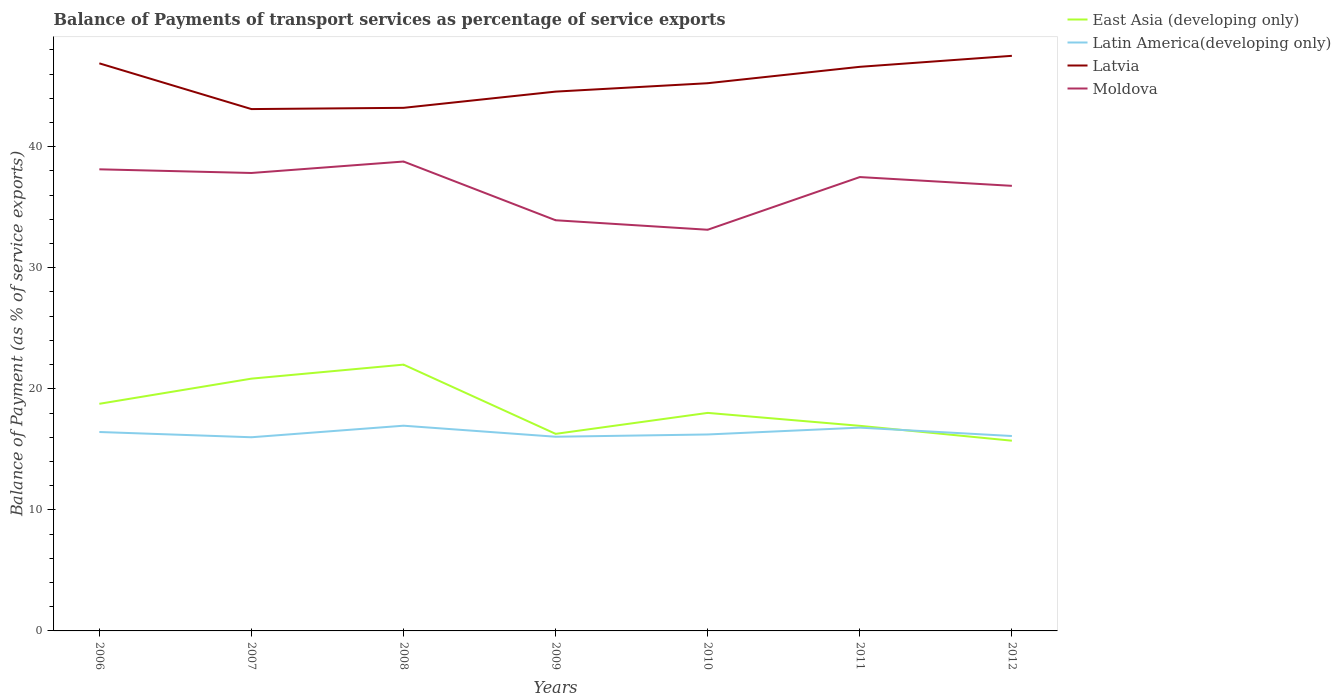How many different coloured lines are there?
Provide a succinct answer. 4. Across all years, what is the maximum balance of payments of transport services in Moldova?
Offer a terse response. 33.14. What is the total balance of payments of transport services in Latin America(developing only) in the graph?
Provide a short and direct response. 0.91. What is the difference between the highest and the second highest balance of payments of transport services in Moldova?
Your answer should be very brief. 5.64. What is the difference between the highest and the lowest balance of payments of transport services in East Asia (developing only)?
Offer a terse response. 3. Is the balance of payments of transport services in Latvia strictly greater than the balance of payments of transport services in Moldova over the years?
Make the answer very short. No. How many lines are there?
Make the answer very short. 4. How many years are there in the graph?
Ensure brevity in your answer.  7. Does the graph contain any zero values?
Offer a terse response. No. Does the graph contain grids?
Provide a short and direct response. No. How many legend labels are there?
Offer a very short reply. 4. What is the title of the graph?
Keep it short and to the point. Balance of Payments of transport services as percentage of service exports. What is the label or title of the X-axis?
Provide a short and direct response. Years. What is the label or title of the Y-axis?
Your response must be concise. Balance of Payment (as % of service exports). What is the Balance of Payment (as % of service exports) of East Asia (developing only) in 2006?
Ensure brevity in your answer.  18.76. What is the Balance of Payment (as % of service exports) of Latin America(developing only) in 2006?
Make the answer very short. 16.43. What is the Balance of Payment (as % of service exports) in Latvia in 2006?
Offer a terse response. 46.89. What is the Balance of Payment (as % of service exports) in Moldova in 2006?
Make the answer very short. 38.13. What is the Balance of Payment (as % of service exports) in East Asia (developing only) in 2007?
Your answer should be compact. 20.84. What is the Balance of Payment (as % of service exports) in Latin America(developing only) in 2007?
Your answer should be compact. 16. What is the Balance of Payment (as % of service exports) in Latvia in 2007?
Ensure brevity in your answer.  43.11. What is the Balance of Payment (as % of service exports) of Moldova in 2007?
Keep it short and to the point. 37.83. What is the Balance of Payment (as % of service exports) of East Asia (developing only) in 2008?
Offer a terse response. 22. What is the Balance of Payment (as % of service exports) in Latin America(developing only) in 2008?
Provide a succinct answer. 16.95. What is the Balance of Payment (as % of service exports) of Latvia in 2008?
Offer a very short reply. 43.21. What is the Balance of Payment (as % of service exports) in Moldova in 2008?
Make the answer very short. 38.78. What is the Balance of Payment (as % of service exports) of East Asia (developing only) in 2009?
Make the answer very short. 16.28. What is the Balance of Payment (as % of service exports) of Latin America(developing only) in 2009?
Your answer should be very brief. 16.04. What is the Balance of Payment (as % of service exports) in Latvia in 2009?
Make the answer very short. 44.55. What is the Balance of Payment (as % of service exports) in Moldova in 2009?
Your answer should be very brief. 33.93. What is the Balance of Payment (as % of service exports) of East Asia (developing only) in 2010?
Your response must be concise. 18.01. What is the Balance of Payment (as % of service exports) of Latin America(developing only) in 2010?
Provide a short and direct response. 16.23. What is the Balance of Payment (as % of service exports) in Latvia in 2010?
Offer a very short reply. 45.25. What is the Balance of Payment (as % of service exports) in Moldova in 2010?
Offer a very short reply. 33.14. What is the Balance of Payment (as % of service exports) in East Asia (developing only) in 2011?
Provide a short and direct response. 16.94. What is the Balance of Payment (as % of service exports) of Latin America(developing only) in 2011?
Give a very brief answer. 16.79. What is the Balance of Payment (as % of service exports) of Latvia in 2011?
Give a very brief answer. 46.6. What is the Balance of Payment (as % of service exports) in Moldova in 2011?
Make the answer very short. 37.49. What is the Balance of Payment (as % of service exports) of East Asia (developing only) in 2012?
Your answer should be very brief. 15.71. What is the Balance of Payment (as % of service exports) in Latin America(developing only) in 2012?
Provide a short and direct response. 16.1. What is the Balance of Payment (as % of service exports) of Latvia in 2012?
Your answer should be compact. 47.51. What is the Balance of Payment (as % of service exports) of Moldova in 2012?
Your answer should be compact. 36.77. Across all years, what is the maximum Balance of Payment (as % of service exports) in East Asia (developing only)?
Make the answer very short. 22. Across all years, what is the maximum Balance of Payment (as % of service exports) of Latin America(developing only)?
Your response must be concise. 16.95. Across all years, what is the maximum Balance of Payment (as % of service exports) of Latvia?
Keep it short and to the point. 47.51. Across all years, what is the maximum Balance of Payment (as % of service exports) in Moldova?
Make the answer very short. 38.78. Across all years, what is the minimum Balance of Payment (as % of service exports) of East Asia (developing only)?
Keep it short and to the point. 15.71. Across all years, what is the minimum Balance of Payment (as % of service exports) in Latin America(developing only)?
Your answer should be compact. 16. Across all years, what is the minimum Balance of Payment (as % of service exports) in Latvia?
Keep it short and to the point. 43.11. Across all years, what is the minimum Balance of Payment (as % of service exports) in Moldova?
Make the answer very short. 33.14. What is the total Balance of Payment (as % of service exports) in East Asia (developing only) in the graph?
Your response must be concise. 128.55. What is the total Balance of Payment (as % of service exports) of Latin America(developing only) in the graph?
Give a very brief answer. 114.55. What is the total Balance of Payment (as % of service exports) of Latvia in the graph?
Offer a very short reply. 317.11. What is the total Balance of Payment (as % of service exports) of Moldova in the graph?
Make the answer very short. 256.07. What is the difference between the Balance of Payment (as % of service exports) in East Asia (developing only) in 2006 and that in 2007?
Offer a terse response. -2.08. What is the difference between the Balance of Payment (as % of service exports) of Latin America(developing only) in 2006 and that in 2007?
Ensure brevity in your answer.  0.43. What is the difference between the Balance of Payment (as % of service exports) in Latvia in 2006 and that in 2007?
Your response must be concise. 3.78. What is the difference between the Balance of Payment (as % of service exports) in Moldova in 2006 and that in 2007?
Your response must be concise. 0.3. What is the difference between the Balance of Payment (as % of service exports) in East Asia (developing only) in 2006 and that in 2008?
Offer a terse response. -3.24. What is the difference between the Balance of Payment (as % of service exports) in Latin America(developing only) in 2006 and that in 2008?
Your answer should be very brief. -0.52. What is the difference between the Balance of Payment (as % of service exports) of Latvia in 2006 and that in 2008?
Provide a succinct answer. 3.67. What is the difference between the Balance of Payment (as % of service exports) of Moldova in 2006 and that in 2008?
Ensure brevity in your answer.  -0.64. What is the difference between the Balance of Payment (as % of service exports) of East Asia (developing only) in 2006 and that in 2009?
Provide a succinct answer. 2.48. What is the difference between the Balance of Payment (as % of service exports) in Latin America(developing only) in 2006 and that in 2009?
Provide a short and direct response. 0.39. What is the difference between the Balance of Payment (as % of service exports) of Latvia in 2006 and that in 2009?
Make the answer very short. 2.33. What is the difference between the Balance of Payment (as % of service exports) of Moldova in 2006 and that in 2009?
Give a very brief answer. 4.21. What is the difference between the Balance of Payment (as % of service exports) of East Asia (developing only) in 2006 and that in 2010?
Make the answer very short. 0.75. What is the difference between the Balance of Payment (as % of service exports) of Latin America(developing only) in 2006 and that in 2010?
Give a very brief answer. 0.2. What is the difference between the Balance of Payment (as % of service exports) in Latvia in 2006 and that in 2010?
Your response must be concise. 1.64. What is the difference between the Balance of Payment (as % of service exports) of Moldova in 2006 and that in 2010?
Provide a succinct answer. 4.99. What is the difference between the Balance of Payment (as % of service exports) in East Asia (developing only) in 2006 and that in 2011?
Provide a short and direct response. 1.82. What is the difference between the Balance of Payment (as % of service exports) of Latin America(developing only) in 2006 and that in 2011?
Your response must be concise. -0.36. What is the difference between the Balance of Payment (as % of service exports) in Latvia in 2006 and that in 2011?
Give a very brief answer. 0.29. What is the difference between the Balance of Payment (as % of service exports) in Moldova in 2006 and that in 2011?
Your answer should be very brief. 0.64. What is the difference between the Balance of Payment (as % of service exports) of East Asia (developing only) in 2006 and that in 2012?
Offer a very short reply. 3.05. What is the difference between the Balance of Payment (as % of service exports) of Latin America(developing only) in 2006 and that in 2012?
Provide a short and direct response. 0.33. What is the difference between the Balance of Payment (as % of service exports) of Latvia in 2006 and that in 2012?
Keep it short and to the point. -0.62. What is the difference between the Balance of Payment (as % of service exports) in Moldova in 2006 and that in 2012?
Provide a short and direct response. 1.36. What is the difference between the Balance of Payment (as % of service exports) in East Asia (developing only) in 2007 and that in 2008?
Your answer should be very brief. -1.16. What is the difference between the Balance of Payment (as % of service exports) in Latin America(developing only) in 2007 and that in 2008?
Your response must be concise. -0.95. What is the difference between the Balance of Payment (as % of service exports) of Latvia in 2007 and that in 2008?
Make the answer very short. -0.1. What is the difference between the Balance of Payment (as % of service exports) in Moldova in 2007 and that in 2008?
Make the answer very short. -0.95. What is the difference between the Balance of Payment (as % of service exports) in East Asia (developing only) in 2007 and that in 2009?
Keep it short and to the point. 4.56. What is the difference between the Balance of Payment (as % of service exports) in Latin America(developing only) in 2007 and that in 2009?
Provide a succinct answer. -0.04. What is the difference between the Balance of Payment (as % of service exports) of Latvia in 2007 and that in 2009?
Offer a terse response. -1.44. What is the difference between the Balance of Payment (as % of service exports) in Moldova in 2007 and that in 2009?
Your answer should be very brief. 3.91. What is the difference between the Balance of Payment (as % of service exports) of East Asia (developing only) in 2007 and that in 2010?
Keep it short and to the point. 2.83. What is the difference between the Balance of Payment (as % of service exports) of Latin America(developing only) in 2007 and that in 2010?
Your answer should be compact. -0.23. What is the difference between the Balance of Payment (as % of service exports) in Latvia in 2007 and that in 2010?
Ensure brevity in your answer.  -2.14. What is the difference between the Balance of Payment (as % of service exports) of Moldova in 2007 and that in 2010?
Give a very brief answer. 4.69. What is the difference between the Balance of Payment (as % of service exports) of East Asia (developing only) in 2007 and that in 2011?
Your answer should be very brief. 3.9. What is the difference between the Balance of Payment (as % of service exports) of Latin America(developing only) in 2007 and that in 2011?
Your response must be concise. -0.79. What is the difference between the Balance of Payment (as % of service exports) of Latvia in 2007 and that in 2011?
Your response must be concise. -3.49. What is the difference between the Balance of Payment (as % of service exports) of Moldova in 2007 and that in 2011?
Your response must be concise. 0.34. What is the difference between the Balance of Payment (as % of service exports) of East Asia (developing only) in 2007 and that in 2012?
Offer a very short reply. 5.13. What is the difference between the Balance of Payment (as % of service exports) in Latin America(developing only) in 2007 and that in 2012?
Your answer should be very brief. -0.1. What is the difference between the Balance of Payment (as % of service exports) in Latvia in 2007 and that in 2012?
Offer a very short reply. -4.4. What is the difference between the Balance of Payment (as % of service exports) of Moldova in 2007 and that in 2012?
Ensure brevity in your answer.  1.06. What is the difference between the Balance of Payment (as % of service exports) of East Asia (developing only) in 2008 and that in 2009?
Keep it short and to the point. 5.72. What is the difference between the Balance of Payment (as % of service exports) in Latin America(developing only) in 2008 and that in 2009?
Offer a terse response. 0.91. What is the difference between the Balance of Payment (as % of service exports) in Latvia in 2008 and that in 2009?
Keep it short and to the point. -1.34. What is the difference between the Balance of Payment (as % of service exports) of Moldova in 2008 and that in 2009?
Offer a very short reply. 4.85. What is the difference between the Balance of Payment (as % of service exports) in East Asia (developing only) in 2008 and that in 2010?
Make the answer very short. 3.99. What is the difference between the Balance of Payment (as % of service exports) of Latin America(developing only) in 2008 and that in 2010?
Provide a short and direct response. 0.72. What is the difference between the Balance of Payment (as % of service exports) in Latvia in 2008 and that in 2010?
Give a very brief answer. -2.03. What is the difference between the Balance of Payment (as % of service exports) of Moldova in 2008 and that in 2010?
Offer a terse response. 5.64. What is the difference between the Balance of Payment (as % of service exports) of East Asia (developing only) in 2008 and that in 2011?
Keep it short and to the point. 5.06. What is the difference between the Balance of Payment (as % of service exports) of Latin America(developing only) in 2008 and that in 2011?
Your answer should be very brief. 0.16. What is the difference between the Balance of Payment (as % of service exports) of Latvia in 2008 and that in 2011?
Offer a terse response. -3.39. What is the difference between the Balance of Payment (as % of service exports) in Moldova in 2008 and that in 2011?
Provide a succinct answer. 1.28. What is the difference between the Balance of Payment (as % of service exports) in East Asia (developing only) in 2008 and that in 2012?
Ensure brevity in your answer.  6.28. What is the difference between the Balance of Payment (as % of service exports) in Latin America(developing only) in 2008 and that in 2012?
Provide a succinct answer. 0.85. What is the difference between the Balance of Payment (as % of service exports) of Latvia in 2008 and that in 2012?
Make the answer very short. -4.3. What is the difference between the Balance of Payment (as % of service exports) in Moldova in 2008 and that in 2012?
Your answer should be compact. 2.01. What is the difference between the Balance of Payment (as % of service exports) of East Asia (developing only) in 2009 and that in 2010?
Provide a succinct answer. -1.73. What is the difference between the Balance of Payment (as % of service exports) of Latin America(developing only) in 2009 and that in 2010?
Your answer should be very brief. -0.19. What is the difference between the Balance of Payment (as % of service exports) in Latvia in 2009 and that in 2010?
Give a very brief answer. -0.69. What is the difference between the Balance of Payment (as % of service exports) in Moldova in 2009 and that in 2010?
Provide a succinct answer. 0.78. What is the difference between the Balance of Payment (as % of service exports) in East Asia (developing only) in 2009 and that in 2011?
Offer a terse response. -0.66. What is the difference between the Balance of Payment (as % of service exports) in Latin America(developing only) in 2009 and that in 2011?
Ensure brevity in your answer.  -0.75. What is the difference between the Balance of Payment (as % of service exports) of Latvia in 2009 and that in 2011?
Make the answer very short. -2.05. What is the difference between the Balance of Payment (as % of service exports) in Moldova in 2009 and that in 2011?
Provide a succinct answer. -3.57. What is the difference between the Balance of Payment (as % of service exports) of East Asia (developing only) in 2009 and that in 2012?
Offer a terse response. 0.56. What is the difference between the Balance of Payment (as % of service exports) in Latin America(developing only) in 2009 and that in 2012?
Give a very brief answer. -0.06. What is the difference between the Balance of Payment (as % of service exports) of Latvia in 2009 and that in 2012?
Make the answer very short. -2.96. What is the difference between the Balance of Payment (as % of service exports) of Moldova in 2009 and that in 2012?
Provide a succinct answer. -2.84. What is the difference between the Balance of Payment (as % of service exports) of East Asia (developing only) in 2010 and that in 2011?
Offer a terse response. 1.07. What is the difference between the Balance of Payment (as % of service exports) of Latin America(developing only) in 2010 and that in 2011?
Provide a succinct answer. -0.56. What is the difference between the Balance of Payment (as % of service exports) of Latvia in 2010 and that in 2011?
Provide a short and direct response. -1.35. What is the difference between the Balance of Payment (as % of service exports) in Moldova in 2010 and that in 2011?
Offer a terse response. -4.35. What is the difference between the Balance of Payment (as % of service exports) in East Asia (developing only) in 2010 and that in 2012?
Ensure brevity in your answer.  2.3. What is the difference between the Balance of Payment (as % of service exports) in Latin America(developing only) in 2010 and that in 2012?
Make the answer very short. 0.13. What is the difference between the Balance of Payment (as % of service exports) in Latvia in 2010 and that in 2012?
Ensure brevity in your answer.  -2.26. What is the difference between the Balance of Payment (as % of service exports) in Moldova in 2010 and that in 2012?
Your response must be concise. -3.63. What is the difference between the Balance of Payment (as % of service exports) in East Asia (developing only) in 2011 and that in 2012?
Ensure brevity in your answer.  1.23. What is the difference between the Balance of Payment (as % of service exports) in Latin America(developing only) in 2011 and that in 2012?
Offer a terse response. 0.69. What is the difference between the Balance of Payment (as % of service exports) in Latvia in 2011 and that in 2012?
Your answer should be compact. -0.91. What is the difference between the Balance of Payment (as % of service exports) of Moldova in 2011 and that in 2012?
Offer a terse response. 0.72. What is the difference between the Balance of Payment (as % of service exports) in East Asia (developing only) in 2006 and the Balance of Payment (as % of service exports) in Latin America(developing only) in 2007?
Keep it short and to the point. 2.76. What is the difference between the Balance of Payment (as % of service exports) in East Asia (developing only) in 2006 and the Balance of Payment (as % of service exports) in Latvia in 2007?
Offer a very short reply. -24.35. What is the difference between the Balance of Payment (as % of service exports) of East Asia (developing only) in 2006 and the Balance of Payment (as % of service exports) of Moldova in 2007?
Keep it short and to the point. -19.07. What is the difference between the Balance of Payment (as % of service exports) in Latin America(developing only) in 2006 and the Balance of Payment (as % of service exports) in Latvia in 2007?
Provide a short and direct response. -26.68. What is the difference between the Balance of Payment (as % of service exports) in Latin America(developing only) in 2006 and the Balance of Payment (as % of service exports) in Moldova in 2007?
Keep it short and to the point. -21.4. What is the difference between the Balance of Payment (as % of service exports) in Latvia in 2006 and the Balance of Payment (as % of service exports) in Moldova in 2007?
Ensure brevity in your answer.  9.06. What is the difference between the Balance of Payment (as % of service exports) of East Asia (developing only) in 2006 and the Balance of Payment (as % of service exports) of Latin America(developing only) in 2008?
Ensure brevity in your answer.  1.81. What is the difference between the Balance of Payment (as % of service exports) in East Asia (developing only) in 2006 and the Balance of Payment (as % of service exports) in Latvia in 2008?
Offer a very short reply. -24.45. What is the difference between the Balance of Payment (as % of service exports) of East Asia (developing only) in 2006 and the Balance of Payment (as % of service exports) of Moldova in 2008?
Offer a very short reply. -20.01. What is the difference between the Balance of Payment (as % of service exports) of Latin America(developing only) in 2006 and the Balance of Payment (as % of service exports) of Latvia in 2008?
Provide a short and direct response. -26.78. What is the difference between the Balance of Payment (as % of service exports) in Latin America(developing only) in 2006 and the Balance of Payment (as % of service exports) in Moldova in 2008?
Offer a very short reply. -22.34. What is the difference between the Balance of Payment (as % of service exports) in Latvia in 2006 and the Balance of Payment (as % of service exports) in Moldova in 2008?
Provide a short and direct response. 8.11. What is the difference between the Balance of Payment (as % of service exports) of East Asia (developing only) in 2006 and the Balance of Payment (as % of service exports) of Latin America(developing only) in 2009?
Your answer should be compact. 2.72. What is the difference between the Balance of Payment (as % of service exports) in East Asia (developing only) in 2006 and the Balance of Payment (as % of service exports) in Latvia in 2009?
Ensure brevity in your answer.  -25.79. What is the difference between the Balance of Payment (as % of service exports) of East Asia (developing only) in 2006 and the Balance of Payment (as % of service exports) of Moldova in 2009?
Provide a succinct answer. -15.16. What is the difference between the Balance of Payment (as % of service exports) in Latin America(developing only) in 2006 and the Balance of Payment (as % of service exports) in Latvia in 2009?
Ensure brevity in your answer.  -28.12. What is the difference between the Balance of Payment (as % of service exports) of Latin America(developing only) in 2006 and the Balance of Payment (as % of service exports) of Moldova in 2009?
Ensure brevity in your answer.  -17.49. What is the difference between the Balance of Payment (as % of service exports) of Latvia in 2006 and the Balance of Payment (as % of service exports) of Moldova in 2009?
Provide a short and direct response. 12.96. What is the difference between the Balance of Payment (as % of service exports) of East Asia (developing only) in 2006 and the Balance of Payment (as % of service exports) of Latin America(developing only) in 2010?
Your answer should be compact. 2.53. What is the difference between the Balance of Payment (as % of service exports) of East Asia (developing only) in 2006 and the Balance of Payment (as % of service exports) of Latvia in 2010?
Make the answer very short. -26.48. What is the difference between the Balance of Payment (as % of service exports) in East Asia (developing only) in 2006 and the Balance of Payment (as % of service exports) in Moldova in 2010?
Give a very brief answer. -14.38. What is the difference between the Balance of Payment (as % of service exports) in Latin America(developing only) in 2006 and the Balance of Payment (as % of service exports) in Latvia in 2010?
Your response must be concise. -28.81. What is the difference between the Balance of Payment (as % of service exports) in Latin America(developing only) in 2006 and the Balance of Payment (as % of service exports) in Moldova in 2010?
Your response must be concise. -16.71. What is the difference between the Balance of Payment (as % of service exports) of Latvia in 2006 and the Balance of Payment (as % of service exports) of Moldova in 2010?
Give a very brief answer. 13.75. What is the difference between the Balance of Payment (as % of service exports) in East Asia (developing only) in 2006 and the Balance of Payment (as % of service exports) in Latin America(developing only) in 2011?
Your answer should be compact. 1.97. What is the difference between the Balance of Payment (as % of service exports) of East Asia (developing only) in 2006 and the Balance of Payment (as % of service exports) of Latvia in 2011?
Your answer should be compact. -27.84. What is the difference between the Balance of Payment (as % of service exports) in East Asia (developing only) in 2006 and the Balance of Payment (as % of service exports) in Moldova in 2011?
Ensure brevity in your answer.  -18.73. What is the difference between the Balance of Payment (as % of service exports) of Latin America(developing only) in 2006 and the Balance of Payment (as % of service exports) of Latvia in 2011?
Make the answer very short. -30.17. What is the difference between the Balance of Payment (as % of service exports) in Latin America(developing only) in 2006 and the Balance of Payment (as % of service exports) in Moldova in 2011?
Your response must be concise. -21.06. What is the difference between the Balance of Payment (as % of service exports) in Latvia in 2006 and the Balance of Payment (as % of service exports) in Moldova in 2011?
Offer a very short reply. 9.39. What is the difference between the Balance of Payment (as % of service exports) of East Asia (developing only) in 2006 and the Balance of Payment (as % of service exports) of Latin America(developing only) in 2012?
Keep it short and to the point. 2.66. What is the difference between the Balance of Payment (as % of service exports) in East Asia (developing only) in 2006 and the Balance of Payment (as % of service exports) in Latvia in 2012?
Provide a short and direct response. -28.75. What is the difference between the Balance of Payment (as % of service exports) in East Asia (developing only) in 2006 and the Balance of Payment (as % of service exports) in Moldova in 2012?
Make the answer very short. -18.01. What is the difference between the Balance of Payment (as % of service exports) of Latin America(developing only) in 2006 and the Balance of Payment (as % of service exports) of Latvia in 2012?
Your answer should be compact. -31.08. What is the difference between the Balance of Payment (as % of service exports) in Latin America(developing only) in 2006 and the Balance of Payment (as % of service exports) in Moldova in 2012?
Your answer should be compact. -20.34. What is the difference between the Balance of Payment (as % of service exports) in Latvia in 2006 and the Balance of Payment (as % of service exports) in Moldova in 2012?
Offer a very short reply. 10.12. What is the difference between the Balance of Payment (as % of service exports) of East Asia (developing only) in 2007 and the Balance of Payment (as % of service exports) of Latin America(developing only) in 2008?
Provide a succinct answer. 3.89. What is the difference between the Balance of Payment (as % of service exports) in East Asia (developing only) in 2007 and the Balance of Payment (as % of service exports) in Latvia in 2008?
Provide a short and direct response. -22.37. What is the difference between the Balance of Payment (as % of service exports) of East Asia (developing only) in 2007 and the Balance of Payment (as % of service exports) of Moldova in 2008?
Offer a terse response. -17.94. What is the difference between the Balance of Payment (as % of service exports) in Latin America(developing only) in 2007 and the Balance of Payment (as % of service exports) in Latvia in 2008?
Your response must be concise. -27.21. What is the difference between the Balance of Payment (as % of service exports) of Latin America(developing only) in 2007 and the Balance of Payment (as % of service exports) of Moldova in 2008?
Provide a short and direct response. -22.78. What is the difference between the Balance of Payment (as % of service exports) of Latvia in 2007 and the Balance of Payment (as % of service exports) of Moldova in 2008?
Your answer should be compact. 4.33. What is the difference between the Balance of Payment (as % of service exports) in East Asia (developing only) in 2007 and the Balance of Payment (as % of service exports) in Latin America(developing only) in 2009?
Provide a short and direct response. 4.8. What is the difference between the Balance of Payment (as % of service exports) of East Asia (developing only) in 2007 and the Balance of Payment (as % of service exports) of Latvia in 2009?
Offer a very short reply. -23.71. What is the difference between the Balance of Payment (as % of service exports) of East Asia (developing only) in 2007 and the Balance of Payment (as % of service exports) of Moldova in 2009?
Your answer should be very brief. -13.08. What is the difference between the Balance of Payment (as % of service exports) of Latin America(developing only) in 2007 and the Balance of Payment (as % of service exports) of Latvia in 2009?
Offer a terse response. -28.55. What is the difference between the Balance of Payment (as % of service exports) of Latin America(developing only) in 2007 and the Balance of Payment (as % of service exports) of Moldova in 2009?
Provide a succinct answer. -17.93. What is the difference between the Balance of Payment (as % of service exports) in Latvia in 2007 and the Balance of Payment (as % of service exports) in Moldova in 2009?
Provide a succinct answer. 9.18. What is the difference between the Balance of Payment (as % of service exports) of East Asia (developing only) in 2007 and the Balance of Payment (as % of service exports) of Latin America(developing only) in 2010?
Make the answer very short. 4.61. What is the difference between the Balance of Payment (as % of service exports) of East Asia (developing only) in 2007 and the Balance of Payment (as % of service exports) of Latvia in 2010?
Make the answer very short. -24.41. What is the difference between the Balance of Payment (as % of service exports) in East Asia (developing only) in 2007 and the Balance of Payment (as % of service exports) in Moldova in 2010?
Keep it short and to the point. -12.3. What is the difference between the Balance of Payment (as % of service exports) in Latin America(developing only) in 2007 and the Balance of Payment (as % of service exports) in Latvia in 2010?
Offer a very short reply. -29.25. What is the difference between the Balance of Payment (as % of service exports) of Latin America(developing only) in 2007 and the Balance of Payment (as % of service exports) of Moldova in 2010?
Provide a succinct answer. -17.14. What is the difference between the Balance of Payment (as % of service exports) of Latvia in 2007 and the Balance of Payment (as % of service exports) of Moldova in 2010?
Your answer should be compact. 9.97. What is the difference between the Balance of Payment (as % of service exports) of East Asia (developing only) in 2007 and the Balance of Payment (as % of service exports) of Latin America(developing only) in 2011?
Your answer should be compact. 4.05. What is the difference between the Balance of Payment (as % of service exports) of East Asia (developing only) in 2007 and the Balance of Payment (as % of service exports) of Latvia in 2011?
Your answer should be compact. -25.76. What is the difference between the Balance of Payment (as % of service exports) of East Asia (developing only) in 2007 and the Balance of Payment (as % of service exports) of Moldova in 2011?
Your answer should be very brief. -16.65. What is the difference between the Balance of Payment (as % of service exports) in Latin America(developing only) in 2007 and the Balance of Payment (as % of service exports) in Latvia in 2011?
Keep it short and to the point. -30.6. What is the difference between the Balance of Payment (as % of service exports) in Latin America(developing only) in 2007 and the Balance of Payment (as % of service exports) in Moldova in 2011?
Offer a terse response. -21.49. What is the difference between the Balance of Payment (as % of service exports) in Latvia in 2007 and the Balance of Payment (as % of service exports) in Moldova in 2011?
Your answer should be very brief. 5.62. What is the difference between the Balance of Payment (as % of service exports) of East Asia (developing only) in 2007 and the Balance of Payment (as % of service exports) of Latin America(developing only) in 2012?
Offer a terse response. 4.74. What is the difference between the Balance of Payment (as % of service exports) in East Asia (developing only) in 2007 and the Balance of Payment (as % of service exports) in Latvia in 2012?
Provide a succinct answer. -26.67. What is the difference between the Balance of Payment (as % of service exports) of East Asia (developing only) in 2007 and the Balance of Payment (as % of service exports) of Moldova in 2012?
Provide a short and direct response. -15.93. What is the difference between the Balance of Payment (as % of service exports) of Latin America(developing only) in 2007 and the Balance of Payment (as % of service exports) of Latvia in 2012?
Offer a terse response. -31.51. What is the difference between the Balance of Payment (as % of service exports) in Latin America(developing only) in 2007 and the Balance of Payment (as % of service exports) in Moldova in 2012?
Your answer should be compact. -20.77. What is the difference between the Balance of Payment (as % of service exports) of Latvia in 2007 and the Balance of Payment (as % of service exports) of Moldova in 2012?
Ensure brevity in your answer.  6.34. What is the difference between the Balance of Payment (as % of service exports) in East Asia (developing only) in 2008 and the Balance of Payment (as % of service exports) in Latin America(developing only) in 2009?
Your answer should be very brief. 5.96. What is the difference between the Balance of Payment (as % of service exports) of East Asia (developing only) in 2008 and the Balance of Payment (as % of service exports) of Latvia in 2009?
Your response must be concise. -22.55. What is the difference between the Balance of Payment (as % of service exports) of East Asia (developing only) in 2008 and the Balance of Payment (as % of service exports) of Moldova in 2009?
Offer a very short reply. -11.93. What is the difference between the Balance of Payment (as % of service exports) of Latin America(developing only) in 2008 and the Balance of Payment (as % of service exports) of Latvia in 2009?
Your response must be concise. -27.6. What is the difference between the Balance of Payment (as % of service exports) of Latin America(developing only) in 2008 and the Balance of Payment (as % of service exports) of Moldova in 2009?
Give a very brief answer. -16.97. What is the difference between the Balance of Payment (as % of service exports) in Latvia in 2008 and the Balance of Payment (as % of service exports) in Moldova in 2009?
Offer a terse response. 9.29. What is the difference between the Balance of Payment (as % of service exports) of East Asia (developing only) in 2008 and the Balance of Payment (as % of service exports) of Latin America(developing only) in 2010?
Your answer should be very brief. 5.77. What is the difference between the Balance of Payment (as % of service exports) of East Asia (developing only) in 2008 and the Balance of Payment (as % of service exports) of Latvia in 2010?
Your answer should be very brief. -23.25. What is the difference between the Balance of Payment (as % of service exports) in East Asia (developing only) in 2008 and the Balance of Payment (as % of service exports) in Moldova in 2010?
Offer a very short reply. -11.14. What is the difference between the Balance of Payment (as % of service exports) of Latin America(developing only) in 2008 and the Balance of Payment (as % of service exports) of Latvia in 2010?
Offer a terse response. -28.29. What is the difference between the Balance of Payment (as % of service exports) of Latin America(developing only) in 2008 and the Balance of Payment (as % of service exports) of Moldova in 2010?
Your answer should be very brief. -16.19. What is the difference between the Balance of Payment (as % of service exports) in Latvia in 2008 and the Balance of Payment (as % of service exports) in Moldova in 2010?
Keep it short and to the point. 10.07. What is the difference between the Balance of Payment (as % of service exports) of East Asia (developing only) in 2008 and the Balance of Payment (as % of service exports) of Latin America(developing only) in 2011?
Offer a very short reply. 5.21. What is the difference between the Balance of Payment (as % of service exports) in East Asia (developing only) in 2008 and the Balance of Payment (as % of service exports) in Latvia in 2011?
Keep it short and to the point. -24.6. What is the difference between the Balance of Payment (as % of service exports) in East Asia (developing only) in 2008 and the Balance of Payment (as % of service exports) in Moldova in 2011?
Your answer should be compact. -15.49. What is the difference between the Balance of Payment (as % of service exports) of Latin America(developing only) in 2008 and the Balance of Payment (as % of service exports) of Latvia in 2011?
Make the answer very short. -29.65. What is the difference between the Balance of Payment (as % of service exports) in Latin America(developing only) in 2008 and the Balance of Payment (as % of service exports) in Moldova in 2011?
Your answer should be compact. -20.54. What is the difference between the Balance of Payment (as % of service exports) in Latvia in 2008 and the Balance of Payment (as % of service exports) in Moldova in 2011?
Provide a short and direct response. 5.72. What is the difference between the Balance of Payment (as % of service exports) in East Asia (developing only) in 2008 and the Balance of Payment (as % of service exports) in Latin America(developing only) in 2012?
Your answer should be compact. 5.9. What is the difference between the Balance of Payment (as % of service exports) of East Asia (developing only) in 2008 and the Balance of Payment (as % of service exports) of Latvia in 2012?
Your answer should be very brief. -25.51. What is the difference between the Balance of Payment (as % of service exports) in East Asia (developing only) in 2008 and the Balance of Payment (as % of service exports) in Moldova in 2012?
Provide a succinct answer. -14.77. What is the difference between the Balance of Payment (as % of service exports) in Latin America(developing only) in 2008 and the Balance of Payment (as % of service exports) in Latvia in 2012?
Provide a short and direct response. -30.56. What is the difference between the Balance of Payment (as % of service exports) in Latin America(developing only) in 2008 and the Balance of Payment (as % of service exports) in Moldova in 2012?
Offer a very short reply. -19.81. What is the difference between the Balance of Payment (as % of service exports) in Latvia in 2008 and the Balance of Payment (as % of service exports) in Moldova in 2012?
Your answer should be very brief. 6.44. What is the difference between the Balance of Payment (as % of service exports) in East Asia (developing only) in 2009 and the Balance of Payment (as % of service exports) in Latin America(developing only) in 2010?
Your answer should be very brief. 0.05. What is the difference between the Balance of Payment (as % of service exports) in East Asia (developing only) in 2009 and the Balance of Payment (as % of service exports) in Latvia in 2010?
Your answer should be compact. -28.97. What is the difference between the Balance of Payment (as % of service exports) of East Asia (developing only) in 2009 and the Balance of Payment (as % of service exports) of Moldova in 2010?
Offer a very short reply. -16.86. What is the difference between the Balance of Payment (as % of service exports) in Latin America(developing only) in 2009 and the Balance of Payment (as % of service exports) in Latvia in 2010?
Keep it short and to the point. -29.2. What is the difference between the Balance of Payment (as % of service exports) in Latin America(developing only) in 2009 and the Balance of Payment (as % of service exports) in Moldova in 2010?
Make the answer very short. -17.1. What is the difference between the Balance of Payment (as % of service exports) of Latvia in 2009 and the Balance of Payment (as % of service exports) of Moldova in 2010?
Your answer should be compact. 11.41. What is the difference between the Balance of Payment (as % of service exports) in East Asia (developing only) in 2009 and the Balance of Payment (as % of service exports) in Latin America(developing only) in 2011?
Ensure brevity in your answer.  -0.51. What is the difference between the Balance of Payment (as % of service exports) in East Asia (developing only) in 2009 and the Balance of Payment (as % of service exports) in Latvia in 2011?
Provide a succinct answer. -30.32. What is the difference between the Balance of Payment (as % of service exports) in East Asia (developing only) in 2009 and the Balance of Payment (as % of service exports) in Moldova in 2011?
Provide a short and direct response. -21.21. What is the difference between the Balance of Payment (as % of service exports) in Latin America(developing only) in 2009 and the Balance of Payment (as % of service exports) in Latvia in 2011?
Provide a short and direct response. -30.56. What is the difference between the Balance of Payment (as % of service exports) of Latin America(developing only) in 2009 and the Balance of Payment (as % of service exports) of Moldova in 2011?
Give a very brief answer. -21.45. What is the difference between the Balance of Payment (as % of service exports) in Latvia in 2009 and the Balance of Payment (as % of service exports) in Moldova in 2011?
Offer a very short reply. 7.06. What is the difference between the Balance of Payment (as % of service exports) in East Asia (developing only) in 2009 and the Balance of Payment (as % of service exports) in Latin America(developing only) in 2012?
Give a very brief answer. 0.18. What is the difference between the Balance of Payment (as % of service exports) of East Asia (developing only) in 2009 and the Balance of Payment (as % of service exports) of Latvia in 2012?
Provide a succinct answer. -31.23. What is the difference between the Balance of Payment (as % of service exports) in East Asia (developing only) in 2009 and the Balance of Payment (as % of service exports) in Moldova in 2012?
Your response must be concise. -20.49. What is the difference between the Balance of Payment (as % of service exports) in Latin America(developing only) in 2009 and the Balance of Payment (as % of service exports) in Latvia in 2012?
Your answer should be compact. -31.47. What is the difference between the Balance of Payment (as % of service exports) in Latin America(developing only) in 2009 and the Balance of Payment (as % of service exports) in Moldova in 2012?
Keep it short and to the point. -20.73. What is the difference between the Balance of Payment (as % of service exports) in Latvia in 2009 and the Balance of Payment (as % of service exports) in Moldova in 2012?
Your answer should be very brief. 7.78. What is the difference between the Balance of Payment (as % of service exports) of East Asia (developing only) in 2010 and the Balance of Payment (as % of service exports) of Latin America(developing only) in 2011?
Offer a very short reply. 1.22. What is the difference between the Balance of Payment (as % of service exports) of East Asia (developing only) in 2010 and the Balance of Payment (as % of service exports) of Latvia in 2011?
Offer a terse response. -28.59. What is the difference between the Balance of Payment (as % of service exports) in East Asia (developing only) in 2010 and the Balance of Payment (as % of service exports) in Moldova in 2011?
Give a very brief answer. -19.48. What is the difference between the Balance of Payment (as % of service exports) in Latin America(developing only) in 2010 and the Balance of Payment (as % of service exports) in Latvia in 2011?
Make the answer very short. -30.37. What is the difference between the Balance of Payment (as % of service exports) in Latin America(developing only) in 2010 and the Balance of Payment (as % of service exports) in Moldova in 2011?
Provide a short and direct response. -21.26. What is the difference between the Balance of Payment (as % of service exports) of Latvia in 2010 and the Balance of Payment (as % of service exports) of Moldova in 2011?
Ensure brevity in your answer.  7.75. What is the difference between the Balance of Payment (as % of service exports) of East Asia (developing only) in 2010 and the Balance of Payment (as % of service exports) of Latin America(developing only) in 2012?
Offer a terse response. 1.91. What is the difference between the Balance of Payment (as % of service exports) of East Asia (developing only) in 2010 and the Balance of Payment (as % of service exports) of Latvia in 2012?
Your answer should be very brief. -29.5. What is the difference between the Balance of Payment (as % of service exports) in East Asia (developing only) in 2010 and the Balance of Payment (as % of service exports) in Moldova in 2012?
Your answer should be compact. -18.76. What is the difference between the Balance of Payment (as % of service exports) in Latin America(developing only) in 2010 and the Balance of Payment (as % of service exports) in Latvia in 2012?
Your answer should be compact. -31.28. What is the difference between the Balance of Payment (as % of service exports) in Latin America(developing only) in 2010 and the Balance of Payment (as % of service exports) in Moldova in 2012?
Offer a very short reply. -20.54. What is the difference between the Balance of Payment (as % of service exports) in Latvia in 2010 and the Balance of Payment (as % of service exports) in Moldova in 2012?
Your response must be concise. 8.48. What is the difference between the Balance of Payment (as % of service exports) of East Asia (developing only) in 2011 and the Balance of Payment (as % of service exports) of Latin America(developing only) in 2012?
Provide a succinct answer. 0.84. What is the difference between the Balance of Payment (as % of service exports) of East Asia (developing only) in 2011 and the Balance of Payment (as % of service exports) of Latvia in 2012?
Provide a short and direct response. -30.57. What is the difference between the Balance of Payment (as % of service exports) in East Asia (developing only) in 2011 and the Balance of Payment (as % of service exports) in Moldova in 2012?
Your answer should be compact. -19.83. What is the difference between the Balance of Payment (as % of service exports) in Latin America(developing only) in 2011 and the Balance of Payment (as % of service exports) in Latvia in 2012?
Offer a terse response. -30.72. What is the difference between the Balance of Payment (as % of service exports) of Latin America(developing only) in 2011 and the Balance of Payment (as % of service exports) of Moldova in 2012?
Your answer should be compact. -19.98. What is the difference between the Balance of Payment (as % of service exports) in Latvia in 2011 and the Balance of Payment (as % of service exports) in Moldova in 2012?
Offer a very short reply. 9.83. What is the average Balance of Payment (as % of service exports) in East Asia (developing only) per year?
Give a very brief answer. 18.36. What is the average Balance of Payment (as % of service exports) of Latin America(developing only) per year?
Offer a very short reply. 16.36. What is the average Balance of Payment (as % of service exports) in Latvia per year?
Keep it short and to the point. 45.3. What is the average Balance of Payment (as % of service exports) in Moldova per year?
Provide a short and direct response. 36.58. In the year 2006, what is the difference between the Balance of Payment (as % of service exports) in East Asia (developing only) and Balance of Payment (as % of service exports) in Latin America(developing only)?
Offer a terse response. 2.33. In the year 2006, what is the difference between the Balance of Payment (as % of service exports) of East Asia (developing only) and Balance of Payment (as % of service exports) of Latvia?
Your answer should be compact. -28.12. In the year 2006, what is the difference between the Balance of Payment (as % of service exports) of East Asia (developing only) and Balance of Payment (as % of service exports) of Moldova?
Offer a terse response. -19.37. In the year 2006, what is the difference between the Balance of Payment (as % of service exports) in Latin America(developing only) and Balance of Payment (as % of service exports) in Latvia?
Your answer should be compact. -30.45. In the year 2006, what is the difference between the Balance of Payment (as % of service exports) in Latin America(developing only) and Balance of Payment (as % of service exports) in Moldova?
Make the answer very short. -21.7. In the year 2006, what is the difference between the Balance of Payment (as % of service exports) in Latvia and Balance of Payment (as % of service exports) in Moldova?
Your response must be concise. 8.75. In the year 2007, what is the difference between the Balance of Payment (as % of service exports) of East Asia (developing only) and Balance of Payment (as % of service exports) of Latin America(developing only)?
Provide a succinct answer. 4.84. In the year 2007, what is the difference between the Balance of Payment (as % of service exports) in East Asia (developing only) and Balance of Payment (as % of service exports) in Latvia?
Provide a short and direct response. -22.27. In the year 2007, what is the difference between the Balance of Payment (as % of service exports) in East Asia (developing only) and Balance of Payment (as % of service exports) in Moldova?
Your answer should be very brief. -16.99. In the year 2007, what is the difference between the Balance of Payment (as % of service exports) of Latin America(developing only) and Balance of Payment (as % of service exports) of Latvia?
Your answer should be very brief. -27.11. In the year 2007, what is the difference between the Balance of Payment (as % of service exports) in Latin America(developing only) and Balance of Payment (as % of service exports) in Moldova?
Offer a very short reply. -21.83. In the year 2007, what is the difference between the Balance of Payment (as % of service exports) in Latvia and Balance of Payment (as % of service exports) in Moldova?
Your answer should be very brief. 5.28. In the year 2008, what is the difference between the Balance of Payment (as % of service exports) of East Asia (developing only) and Balance of Payment (as % of service exports) of Latin America(developing only)?
Offer a very short reply. 5.04. In the year 2008, what is the difference between the Balance of Payment (as % of service exports) in East Asia (developing only) and Balance of Payment (as % of service exports) in Latvia?
Your answer should be very brief. -21.21. In the year 2008, what is the difference between the Balance of Payment (as % of service exports) of East Asia (developing only) and Balance of Payment (as % of service exports) of Moldova?
Provide a succinct answer. -16.78. In the year 2008, what is the difference between the Balance of Payment (as % of service exports) of Latin America(developing only) and Balance of Payment (as % of service exports) of Latvia?
Keep it short and to the point. -26.26. In the year 2008, what is the difference between the Balance of Payment (as % of service exports) in Latin America(developing only) and Balance of Payment (as % of service exports) in Moldova?
Your response must be concise. -21.82. In the year 2008, what is the difference between the Balance of Payment (as % of service exports) in Latvia and Balance of Payment (as % of service exports) in Moldova?
Provide a succinct answer. 4.44. In the year 2009, what is the difference between the Balance of Payment (as % of service exports) in East Asia (developing only) and Balance of Payment (as % of service exports) in Latin America(developing only)?
Provide a short and direct response. 0.24. In the year 2009, what is the difference between the Balance of Payment (as % of service exports) in East Asia (developing only) and Balance of Payment (as % of service exports) in Latvia?
Your answer should be compact. -28.27. In the year 2009, what is the difference between the Balance of Payment (as % of service exports) in East Asia (developing only) and Balance of Payment (as % of service exports) in Moldova?
Give a very brief answer. -17.65. In the year 2009, what is the difference between the Balance of Payment (as % of service exports) in Latin America(developing only) and Balance of Payment (as % of service exports) in Latvia?
Ensure brevity in your answer.  -28.51. In the year 2009, what is the difference between the Balance of Payment (as % of service exports) in Latin America(developing only) and Balance of Payment (as % of service exports) in Moldova?
Offer a very short reply. -17.88. In the year 2009, what is the difference between the Balance of Payment (as % of service exports) of Latvia and Balance of Payment (as % of service exports) of Moldova?
Ensure brevity in your answer.  10.63. In the year 2010, what is the difference between the Balance of Payment (as % of service exports) of East Asia (developing only) and Balance of Payment (as % of service exports) of Latin America(developing only)?
Provide a succinct answer. 1.78. In the year 2010, what is the difference between the Balance of Payment (as % of service exports) of East Asia (developing only) and Balance of Payment (as % of service exports) of Latvia?
Keep it short and to the point. -27.23. In the year 2010, what is the difference between the Balance of Payment (as % of service exports) in East Asia (developing only) and Balance of Payment (as % of service exports) in Moldova?
Your answer should be compact. -15.13. In the year 2010, what is the difference between the Balance of Payment (as % of service exports) in Latin America(developing only) and Balance of Payment (as % of service exports) in Latvia?
Offer a terse response. -29.02. In the year 2010, what is the difference between the Balance of Payment (as % of service exports) of Latin America(developing only) and Balance of Payment (as % of service exports) of Moldova?
Provide a short and direct response. -16.91. In the year 2010, what is the difference between the Balance of Payment (as % of service exports) of Latvia and Balance of Payment (as % of service exports) of Moldova?
Your response must be concise. 12.1. In the year 2011, what is the difference between the Balance of Payment (as % of service exports) of East Asia (developing only) and Balance of Payment (as % of service exports) of Latin America(developing only)?
Your answer should be very brief. 0.15. In the year 2011, what is the difference between the Balance of Payment (as % of service exports) of East Asia (developing only) and Balance of Payment (as % of service exports) of Latvia?
Offer a very short reply. -29.66. In the year 2011, what is the difference between the Balance of Payment (as % of service exports) in East Asia (developing only) and Balance of Payment (as % of service exports) in Moldova?
Provide a short and direct response. -20.55. In the year 2011, what is the difference between the Balance of Payment (as % of service exports) of Latin America(developing only) and Balance of Payment (as % of service exports) of Latvia?
Your answer should be compact. -29.81. In the year 2011, what is the difference between the Balance of Payment (as % of service exports) in Latin America(developing only) and Balance of Payment (as % of service exports) in Moldova?
Keep it short and to the point. -20.7. In the year 2011, what is the difference between the Balance of Payment (as % of service exports) of Latvia and Balance of Payment (as % of service exports) of Moldova?
Provide a short and direct response. 9.11. In the year 2012, what is the difference between the Balance of Payment (as % of service exports) in East Asia (developing only) and Balance of Payment (as % of service exports) in Latin America(developing only)?
Ensure brevity in your answer.  -0.39. In the year 2012, what is the difference between the Balance of Payment (as % of service exports) in East Asia (developing only) and Balance of Payment (as % of service exports) in Latvia?
Your answer should be very brief. -31.79. In the year 2012, what is the difference between the Balance of Payment (as % of service exports) of East Asia (developing only) and Balance of Payment (as % of service exports) of Moldova?
Your response must be concise. -21.05. In the year 2012, what is the difference between the Balance of Payment (as % of service exports) of Latin America(developing only) and Balance of Payment (as % of service exports) of Latvia?
Offer a very short reply. -31.41. In the year 2012, what is the difference between the Balance of Payment (as % of service exports) in Latin America(developing only) and Balance of Payment (as % of service exports) in Moldova?
Your answer should be very brief. -20.67. In the year 2012, what is the difference between the Balance of Payment (as % of service exports) of Latvia and Balance of Payment (as % of service exports) of Moldova?
Your answer should be very brief. 10.74. What is the ratio of the Balance of Payment (as % of service exports) in East Asia (developing only) in 2006 to that in 2007?
Ensure brevity in your answer.  0.9. What is the ratio of the Balance of Payment (as % of service exports) of Latin America(developing only) in 2006 to that in 2007?
Your answer should be compact. 1.03. What is the ratio of the Balance of Payment (as % of service exports) of Latvia in 2006 to that in 2007?
Your response must be concise. 1.09. What is the ratio of the Balance of Payment (as % of service exports) of East Asia (developing only) in 2006 to that in 2008?
Offer a terse response. 0.85. What is the ratio of the Balance of Payment (as % of service exports) of Latin America(developing only) in 2006 to that in 2008?
Offer a terse response. 0.97. What is the ratio of the Balance of Payment (as % of service exports) of Latvia in 2006 to that in 2008?
Give a very brief answer. 1.08. What is the ratio of the Balance of Payment (as % of service exports) in Moldova in 2006 to that in 2008?
Your response must be concise. 0.98. What is the ratio of the Balance of Payment (as % of service exports) in East Asia (developing only) in 2006 to that in 2009?
Ensure brevity in your answer.  1.15. What is the ratio of the Balance of Payment (as % of service exports) of Latin America(developing only) in 2006 to that in 2009?
Your response must be concise. 1.02. What is the ratio of the Balance of Payment (as % of service exports) in Latvia in 2006 to that in 2009?
Give a very brief answer. 1.05. What is the ratio of the Balance of Payment (as % of service exports) in Moldova in 2006 to that in 2009?
Keep it short and to the point. 1.12. What is the ratio of the Balance of Payment (as % of service exports) in East Asia (developing only) in 2006 to that in 2010?
Provide a short and direct response. 1.04. What is the ratio of the Balance of Payment (as % of service exports) in Latin America(developing only) in 2006 to that in 2010?
Offer a terse response. 1.01. What is the ratio of the Balance of Payment (as % of service exports) of Latvia in 2006 to that in 2010?
Provide a succinct answer. 1.04. What is the ratio of the Balance of Payment (as % of service exports) of Moldova in 2006 to that in 2010?
Give a very brief answer. 1.15. What is the ratio of the Balance of Payment (as % of service exports) in East Asia (developing only) in 2006 to that in 2011?
Give a very brief answer. 1.11. What is the ratio of the Balance of Payment (as % of service exports) in Latin America(developing only) in 2006 to that in 2011?
Offer a very short reply. 0.98. What is the ratio of the Balance of Payment (as % of service exports) of Latvia in 2006 to that in 2011?
Offer a very short reply. 1.01. What is the ratio of the Balance of Payment (as % of service exports) of Moldova in 2006 to that in 2011?
Your response must be concise. 1.02. What is the ratio of the Balance of Payment (as % of service exports) in East Asia (developing only) in 2006 to that in 2012?
Your response must be concise. 1.19. What is the ratio of the Balance of Payment (as % of service exports) in Latin America(developing only) in 2006 to that in 2012?
Make the answer very short. 1.02. What is the ratio of the Balance of Payment (as % of service exports) of Latvia in 2006 to that in 2012?
Provide a succinct answer. 0.99. What is the ratio of the Balance of Payment (as % of service exports) of Moldova in 2006 to that in 2012?
Give a very brief answer. 1.04. What is the ratio of the Balance of Payment (as % of service exports) in Latin America(developing only) in 2007 to that in 2008?
Provide a succinct answer. 0.94. What is the ratio of the Balance of Payment (as % of service exports) of Latvia in 2007 to that in 2008?
Keep it short and to the point. 1. What is the ratio of the Balance of Payment (as % of service exports) in Moldova in 2007 to that in 2008?
Provide a succinct answer. 0.98. What is the ratio of the Balance of Payment (as % of service exports) of East Asia (developing only) in 2007 to that in 2009?
Your answer should be very brief. 1.28. What is the ratio of the Balance of Payment (as % of service exports) of Latin America(developing only) in 2007 to that in 2009?
Provide a succinct answer. 1. What is the ratio of the Balance of Payment (as % of service exports) in Latvia in 2007 to that in 2009?
Your answer should be compact. 0.97. What is the ratio of the Balance of Payment (as % of service exports) of Moldova in 2007 to that in 2009?
Provide a succinct answer. 1.12. What is the ratio of the Balance of Payment (as % of service exports) of East Asia (developing only) in 2007 to that in 2010?
Provide a short and direct response. 1.16. What is the ratio of the Balance of Payment (as % of service exports) in Latin America(developing only) in 2007 to that in 2010?
Give a very brief answer. 0.99. What is the ratio of the Balance of Payment (as % of service exports) in Latvia in 2007 to that in 2010?
Keep it short and to the point. 0.95. What is the ratio of the Balance of Payment (as % of service exports) in Moldova in 2007 to that in 2010?
Your answer should be very brief. 1.14. What is the ratio of the Balance of Payment (as % of service exports) in East Asia (developing only) in 2007 to that in 2011?
Offer a very short reply. 1.23. What is the ratio of the Balance of Payment (as % of service exports) in Latin America(developing only) in 2007 to that in 2011?
Give a very brief answer. 0.95. What is the ratio of the Balance of Payment (as % of service exports) in Latvia in 2007 to that in 2011?
Offer a terse response. 0.93. What is the ratio of the Balance of Payment (as % of service exports) of East Asia (developing only) in 2007 to that in 2012?
Your answer should be very brief. 1.33. What is the ratio of the Balance of Payment (as % of service exports) in Latvia in 2007 to that in 2012?
Your answer should be very brief. 0.91. What is the ratio of the Balance of Payment (as % of service exports) of Moldova in 2007 to that in 2012?
Ensure brevity in your answer.  1.03. What is the ratio of the Balance of Payment (as % of service exports) of East Asia (developing only) in 2008 to that in 2009?
Your answer should be very brief. 1.35. What is the ratio of the Balance of Payment (as % of service exports) in Latin America(developing only) in 2008 to that in 2009?
Offer a very short reply. 1.06. What is the ratio of the Balance of Payment (as % of service exports) in Latvia in 2008 to that in 2009?
Your response must be concise. 0.97. What is the ratio of the Balance of Payment (as % of service exports) in Moldova in 2008 to that in 2009?
Your answer should be compact. 1.14. What is the ratio of the Balance of Payment (as % of service exports) of East Asia (developing only) in 2008 to that in 2010?
Ensure brevity in your answer.  1.22. What is the ratio of the Balance of Payment (as % of service exports) in Latin America(developing only) in 2008 to that in 2010?
Offer a very short reply. 1.04. What is the ratio of the Balance of Payment (as % of service exports) in Latvia in 2008 to that in 2010?
Ensure brevity in your answer.  0.96. What is the ratio of the Balance of Payment (as % of service exports) of Moldova in 2008 to that in 2010?
Your answer should be compact. 1.17. What is the ratio of the Balance of Payment (as % of service exports) in East Asia (developing only) in 2008 to that in 2011?
Provide a short and direct response. 1.3. What is the ratio of the Balance of Payment (as % of service exports) in Latin America(developing only) in 2008 to that in 2011?
Ensure brevity in your answer.  1.01. What is the ratio of the Balance of Payment (as % of service exports) in Latvia in 2008 to that in 2011?
Your answer should be very brief. 0.93. What is the ratio of the Balance of Payment (as % of service exports) in Moldova in 2008 to that in 2011?
Make the answer very short. 1.03. What is the ratio of the Balance of Payment (as % of service exports) of East Asia (developing only) in 2008 to that in 2012?
Keep it short and to the point. 1.4. What is the ratio of the Balance of Payment (as % of service exports) of Latin America(developing only) in 2008 to that in 2012?
Offer a terse response. 1.05. What is the ratio of the Balance of Payment (as % of service exports) of Latvia in 2008 to that in 2012?
Make the answer very short. 0.91. What is the ratio of the Balance of Payment (as % of service exports) in Moldova in 2008 to that in 2012?
Your answer should be compact. 1.05. What is the ratio of the Balance of Payment (as % of service exports) of East Asia (developing only) in 2009 to that in 2010?
Your answer should be compact. 0.9. What is the ratio of the Balance of Payment (as % of service exports) in Latin America(developing only) in 2009 to that in 2010?
Offer a terse response. 0.99. What is the ratio of the Balance of Payment (as % of service exports) in Latvia in 2009 to that in 2010?
Provide a short and direct response. 0.98. What is the ratio of the Balance of Payment (as % of service exports) of Moldova in 2009 to that in 2010?
Give a very brief answer. 1.02. What is the ratio of the Balance of Payment (as % of service exports) of East Asia (developing only) in 2009 to that in 2011?
Offer a terse response. 0.96. What is the ratio of the Balance of Payment (as % of service exports) of Latin America(developing only) in 2009 to that in 2011?
Offer a terse response. 0.96. What is the ratio of the Balance of Payment (as % of service exports) of Latvia in 2009 to that in 2011?
Your response must be concise. 0.96. What is the ratio of the Balance of Payment (as % of service exports) in Moldova in 2009 to that in 2011?
Ensure brevity in your answer.  0.9. What is the ratio of the Balance of Payment (as % of service exports) in East Asia (developing only) in 2009 to that in 2012?
Offer a terse response. 1.04. What is the ratio of the Balance of Payment (as % of service exports) in Latvia in 2009 to that in 2012?
Your response must be concise. 0.94. What is the ratio of the Balance of Payment (as % of service exports) of Moldova in 2009 to that in 2012?
Ensure brevity in your answer.  0.92. What is the ratio of the Balance of Payment (as % of service exports) of East Asia (developing only) in 2010 to that in 2011?
Offer a terse response. 1.06. What is the ratio of the Balance of Payment (as % of service exports) of Latin America(developing only) in 2010 to that in 2011?
Offer a very short reply. 0.97. What is the ratio of the Balance of Payment (as % of service exports) of Latvia in 2010 to that in 2011?
Provide a short and direct response. 0.97. What is the ratio of the Balance of Payment (as % of service exports) of Moldova in 2010 to that in 2011?
Make the answer very short. 0.88. What is the ratio of the Balance of Payment (as % of service exports) of East Asia (developing only) in 2010 to that in 2012?
Your answer should be compact. 1.15. What is the ratio of the Balance of Payment (as % of service exports) in Latin America(developing only) in 2010 to that in 2012?
Offer a terse response. 1.01. What is the ratio of the Balance of Payment (as % of service exports) of Moldova in 2010 to that in 2012?
Your answer should be compact. 0.9. What is the ratio of the Balance of Payment (as % of service exports) of East Asia (developing only) in 2011 to that in 2012?
Your answer should be very brief. 1.08. What is the ratio of the Balance of Payment (as % of service exports) in Latin America(developing only) in 2011 to that in 2012?
Ensure brevity in your answer.  1.04. What is the ratio of the Balance of Payment (as % of service exports) of Latvia in 2011 to that in 2012?
Offer a terse response. 0.98. What is the ratio of the Balance of Payment (as % of service exports) of Moldova in 2011 to that in 2012?
Make the answer very short. 1.02. What is the difference between the highest and the second highest Balance of Payment (as % of service exports) of East Asia (developing only)?
Ensure brevity in your answer.  1.16. What is the difference between the highest and the second highest Balance of Payment (as % of service exports) of Latin America(developing only)?
Keep it short and to the point. 0.16. What is the difference between the highest and the second highest Balance of Payment (as % of service exports) of Latvia?
Offer a very short reply. 0.62. What is the difference between the highest and the second highest Balance of Payment (as % of service exports) of Moldova?
Offer a terse response. 0.64. What is the difference between the highest and the lowest Balance of Payment (as % of service exports) in East Asia (developing only)?
Your answer should be compact. 6.28. What is the difference between the highest and the lowest Balance of Payment (as % of service exports) of Latin America(developing only)?
Provide a succinct answer. 0.95. What is the difference between the highest and the lowest Balance of Payment (as % of service exports) of Latvia?
Your answer should be compact. 4.4. What is the difference between the highest and the lowest Balance of Payment (as % of service exports) of Moldova?
Keep it short and to the point. 5.64. 